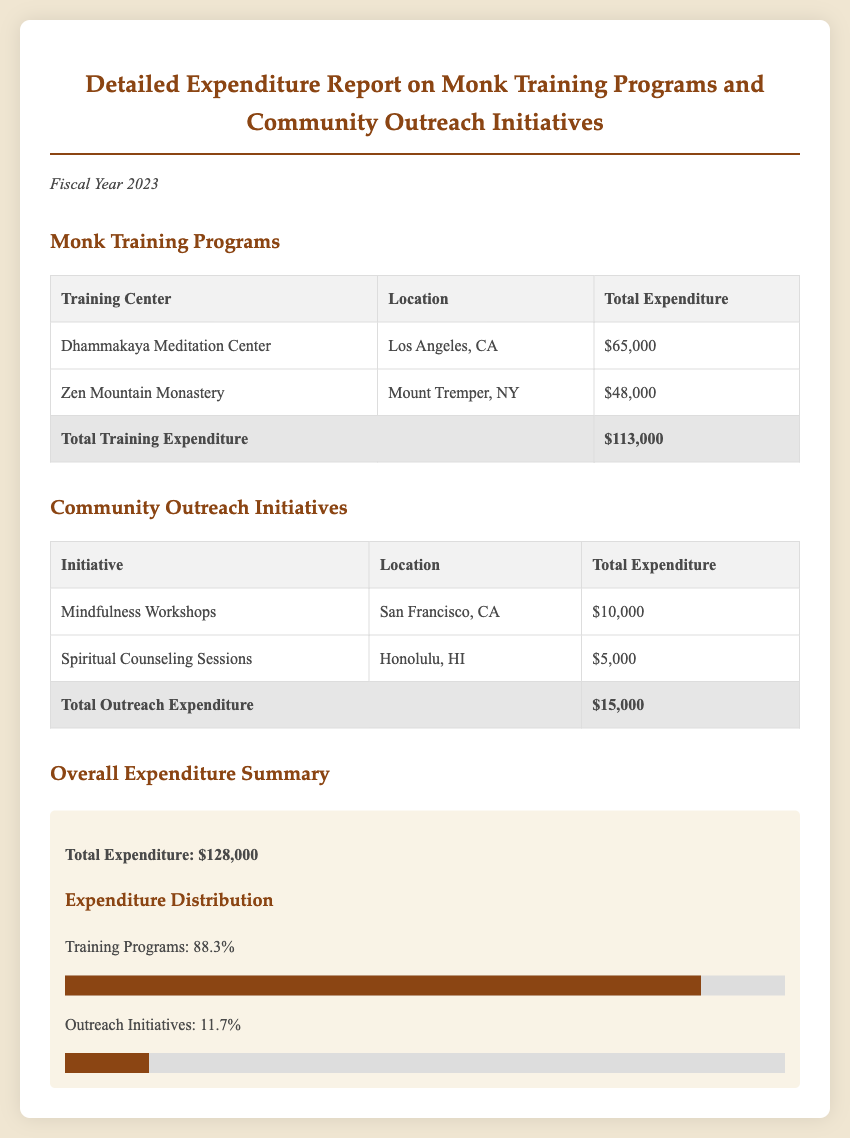What is the total expenditure on monk training programs? The total expenditure on monk training programs is found in the table under "Total Training Expenditure."
Answer: $113,000 What percentage of total expenditure is dedicated to outreach initiatives? The percentage dedicated to outreach initiatives is calculated from the overall expenditure summary section.
Answer: 11.7% Which training center has the highest expenditure? The details of the expenditures for each training center are listed, allowing for easy identification of the highest.
Answer: Dhammakaya Meditation Center What is the total expenditure for mindfulness workshops? Information about mindfulness workshops is found in the community outreach initiatives table.
Answer: $10,000 How much was spent on spiritual counseling sessions? The expenditure is specified in the community outreach initiatives table.
Answer: $5,000 What is the total overall expenditure for the fiscal year 2023? The total overall expenditure is summarized at the bottom of the financial report.
Answer: $128,000 How many training centers are listed in the report? The number of training centers can be counted from the monk training programs section.
Answer: 2 What city hosts the Zen Mountain Monastery? The location of the Zen Mountain Monastery can be found in the training programs table.
Answer: Mount Tremper, NY 